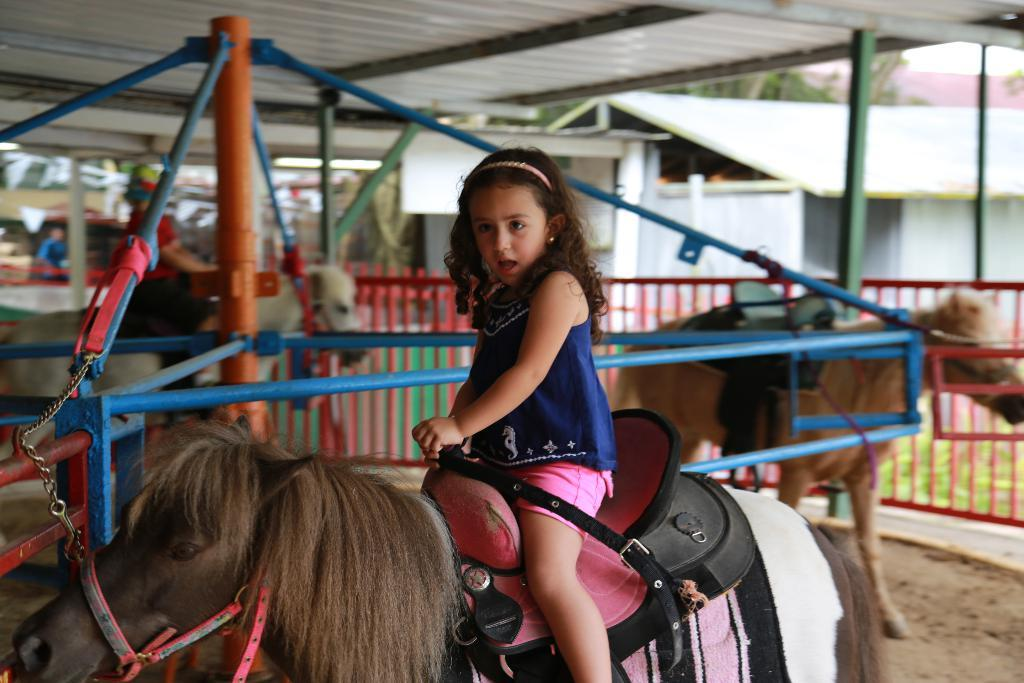Who is the main subject in the image? There is a girl in the image. What is the girl doing in the image? The girl is on a horse. What can be seen in the background of the image? There is a pole in the background of the image. What type of structure is visible in the image? There is a roof visible in the image. What type of knife is the girl using to cut the horse's mane in the image? There is no knife present in the image, nor is the girl cutting the horse's mane. 